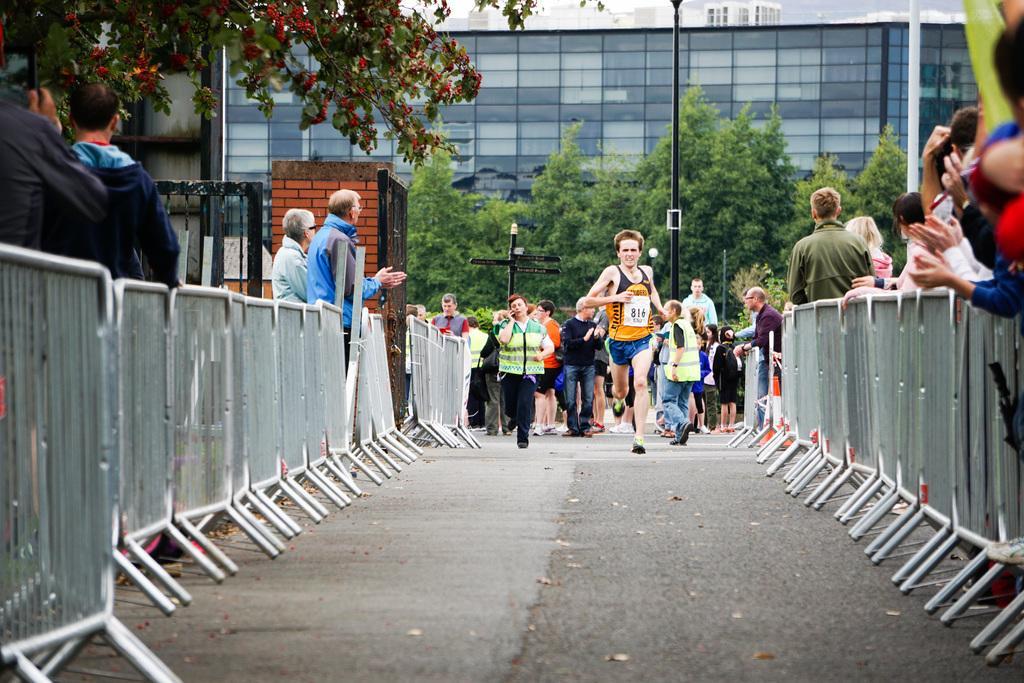In one or two sentences, can you explain what this image depicts? In this image at the bottom there is a walkway, on the walkway there are some people who are running and on the right side and left side there is a fence and some persons are standing. And in the background there are some trees, poles and buildings. 